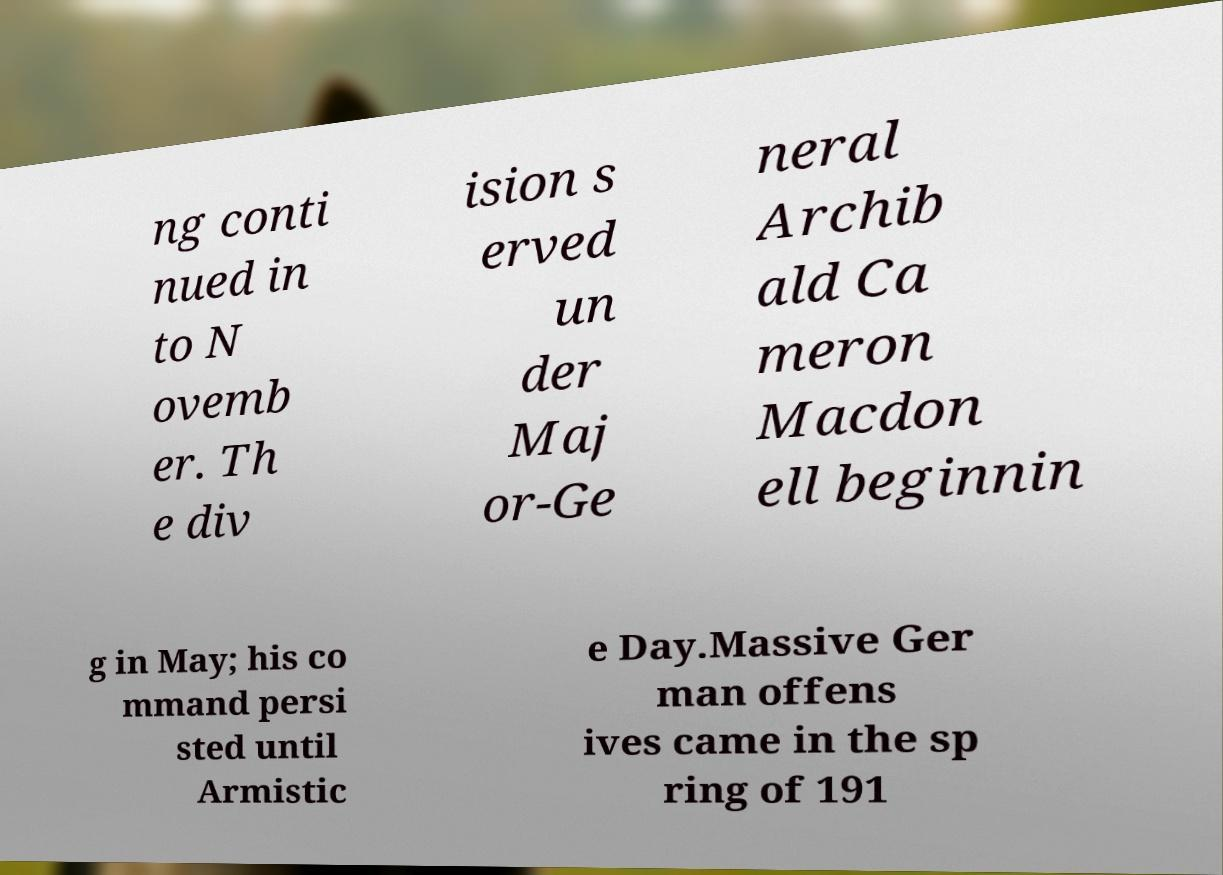Please identify and transcribe the text found in this image. ng conti nued in to N ovemb er. Th e div ision s erved un der Maj or-Ge neral Archib ald Ca meron Macdon ell beginnin g in May; his co mmand persi sted until Armistic e Day.Massive Ger man offens ives came in the sp ring of 191 